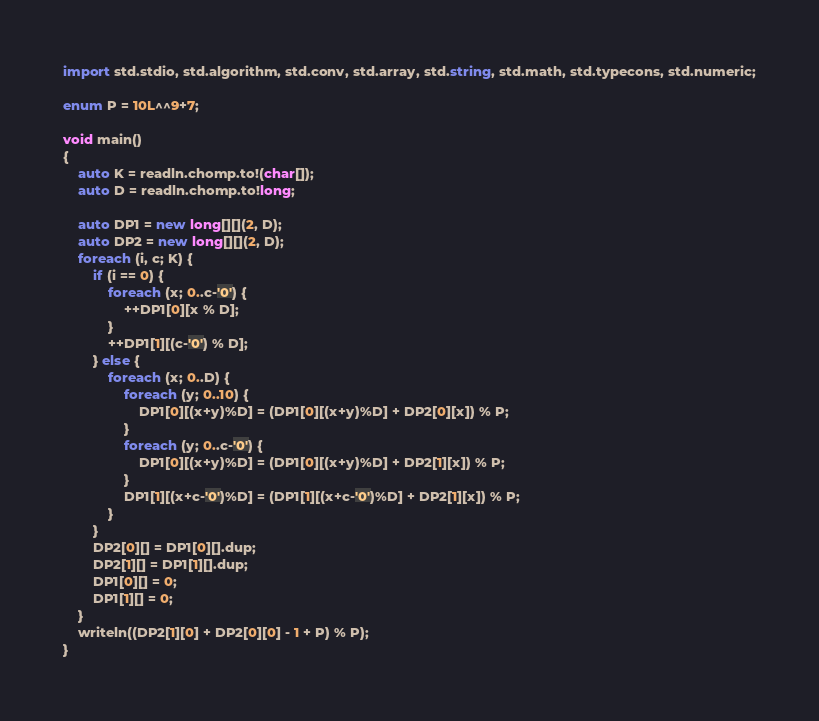<code> <loc_0><loc_0><loc_500><loc_500><_D_>import std.stdio, std.algorithm, std.conv, std.array, std.string, std.math, std.typecons, std.numeric;

enum P = 10L^^9+7;

void main()
{
    auto K = readln.chomp.to!(char[]);
    auto D = readln.chomp.to!long;

    auto DP1 = new long[][](2, D);
    auto DP2 = new long[][](2, D);
    foreach (i, c; K) {
        if (i == 0) {
            foreach (x; 0..c-'0') {
                ++DP1[0][x % D];
            }
            ++DP1[1][(c-'0') % D];
        } else {
            foreach (x; 0..D) {
                foreach (y; 0..10) {
                    DP1[0][(x+y)%D] = (DP1[0][(x+y)%D] + DP2[0][x]) % P;
                }
                foreach (y; 0..c-'0') {
                    DP1[0][(x+y)%D] = (DP1[0][(x+y)%D] + DP2[1][x]) % P;
                }
                DP1[1][(x+c-'0')%D] = (DP1[1][(x+c-'0')%D] + DP2[1][x]) % P;
            }
        }
        DP2[0][] = DP1[0][].dup;
        DP2[1][] = DP1[1][].dup;
        DP1[0][] = 0;
        DP1[1][] = 0;
    }
    writeln((DP2[1][0] + DP2[0][0] - 1 + P) % P);
}</code> 